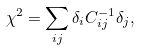<formula> <loc_0><loc_0><loc_500><loc_500>\chi ^ { 2 } = \sum _ { i j } \delta _ { i } C ^ { - 1 } _ { i j } \delta _ { j } ,</formula> 